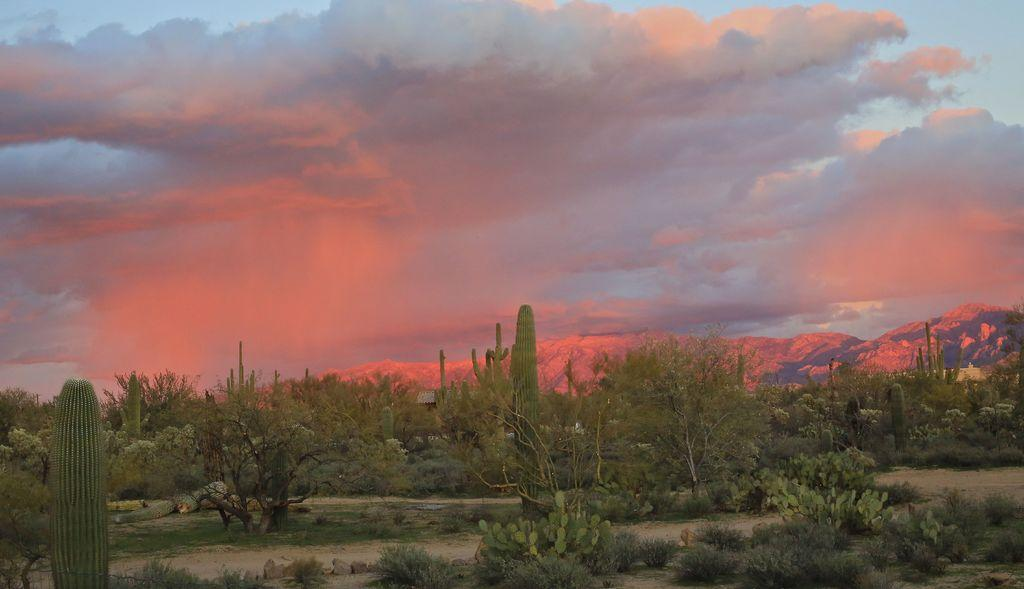What type of vegetation can be seen in the image? There are trees, plants, and grass visible in the image. What other natural elements can be seen in the image? There are stones and sand visible in the image. What is visible in the background of the image? Mountains and the sky are visible in the background of the image. What can be seen in the sky? Clouds are present in the sky. How many ladybugs can be seen on the grass in the image? There are no ladybugs present in the image; it only features trees, plants, grass, stones, sand, mountains, and the sky. What type of drink is being served on the table in the image? There is no table or drink present in the image. 